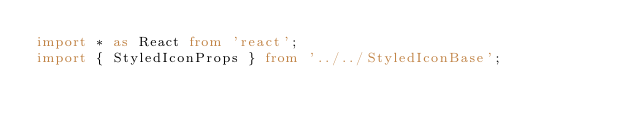<code> <loc_0><loc_0><loc_500><loc_500><_TypeScript_>import * as React from 'react';
import { StyledIconProps } from '../../StyledIconBase';</code> 